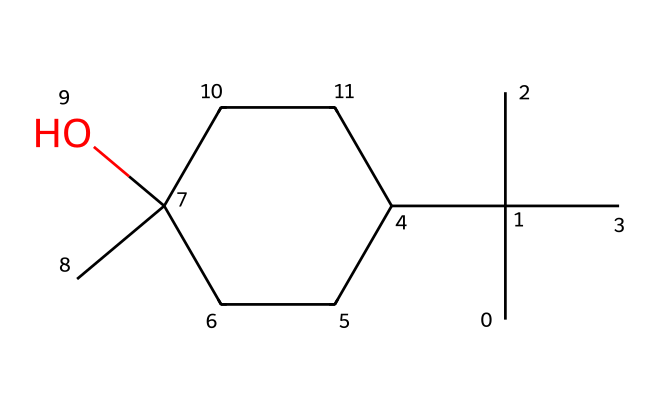What is the molecular formula of menthol? To determine the molecular formula, count the number of each type of atom in the SMILES representation. There are 10 carbon (C) atoms, 20 hydrogen (H) atoms, and 1 oxygen (O) atom. Combine these to form C10H20O.
Answer: C10H20O How many stereogenic centers are present in menthol? By examining the structure, identify the carbon atoms that have four different substituents. In menthol, there are three such carbon atoms, making them stereogenic centers.
Answer: 3 What type of chemical structure does menthol possess? The structure of menthol can be classified as a terpenoid due to its complex arrangement made up of isoprene units. It specifically displays a cyclic structure with hydroxyl functional group.
Answer: terpenoid Which functional group is present in menthol? In the structure, there is a hydroxyl (-OH) group attached to one of the carbon atoms, which defines menthol as an alcohol.
Answer: alcohol Can menthol be classified as a chiral molecule? Since menthol has stereogenic centers, the molecule exhibits chirality, indicating that it can exist in two enantiomeric forms. This is a result of the arrangement around the chiral carbon atoms.
Answer: yes What is the main sensory property of menthol? The chemical structure of menthol, particularly the presence of the hydroxyl group and its specific arrangement, enables it to stimulate the cold-sensitive receptors in the skin, giving it a cooling sensation.
Answer: cooling 